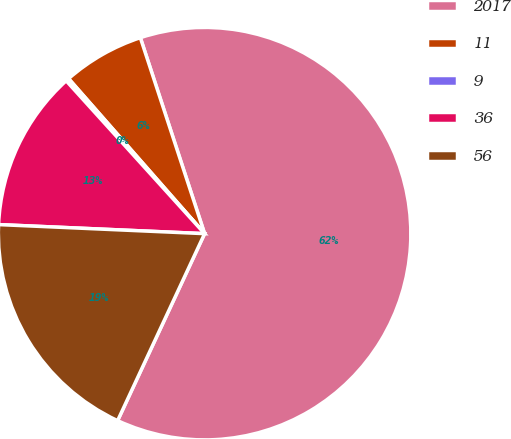Convert chart. <chart><loc_0><loc_0><loc_500><loc_500><pie_chart><fcel>2017<fcel>11<fcel>9<fcel>36<fcel>56<nl><fcel>61.98%<fcel>6.42%<fcel>0.25%<fcel>12.59%<fcel>18.77%<nl></chart> 